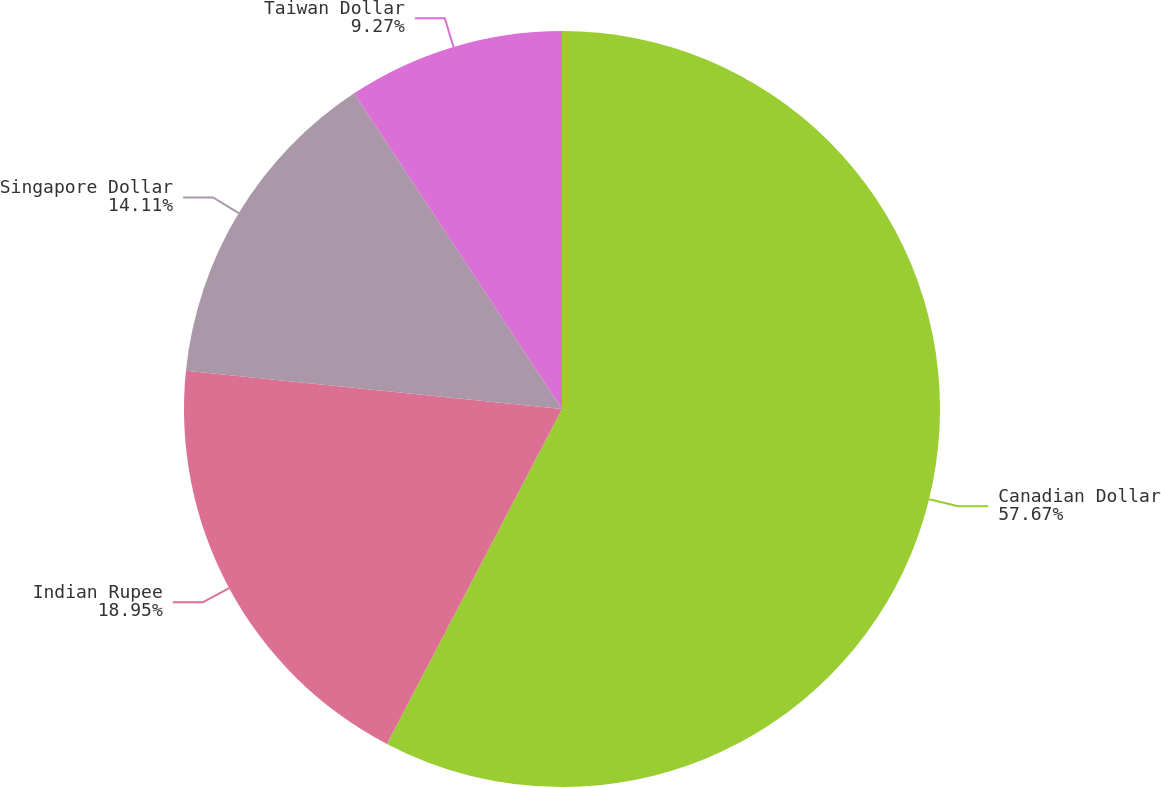Convert chart. <chart><loc_0><loc_0><loc_500><loc_500><pie_chart><fcel>Canadian Dollar<fcel>Indian Rupee<fcel>Singapore Dollar<fcel>Taiwan Dollar<nl><fcel>57.66%<fcel>18.95%<fcel>14.11%<fcel>9.27%<nl></chart> 